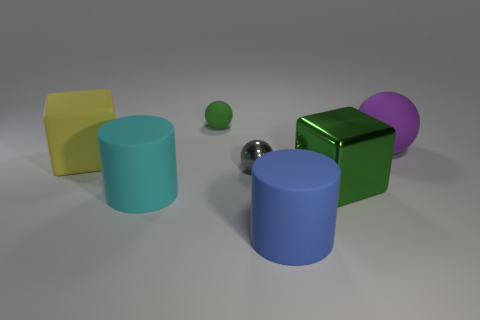What number of matte things are both in front of the large purple thing and on the left side of the small gray metal object?
Keep it short and to the point. 2. What material is the big cube in front of the large rubber cube?
Your response must be concise. Metal. There is a purple ball that is made of the same material as the small green sphere; what is its size?
Your answer should be very brief. Large. There is a cylinder that is to the right of the tiny green matte sphere; is its size the same as the matte thing right of the big shiny block?
Your answer should be very brief. Yes. There is a purple ball that is the same size as the blue rubber object; what is it made of?
Your answer should be compact. Rubber. The ball that is both to the left of the big purple object and behind the yellow object is made of what material?
Provide a short and direct response. Rubber. Is there a cyan cylinder?
Provide a succinct answer. Yes. There is a large metal cube; is it the same color as the matte object behind the big rubber ball?
Your answer should be very brief. Yes. What material is the small thing that is the same color as the large shiny block?
Ensure brevity in your answer.  Rubber. What is the shape of the green thing that is on the left side of the matte cylinder that is to the right of the green thing behind the big yellow object?
Give a very brief answer. Sphere. 